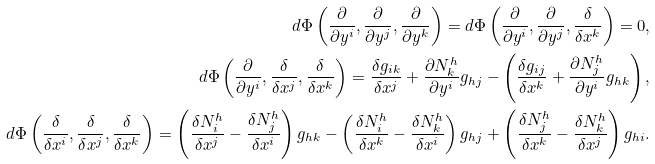<formula> <loc_0><loc_0><loc_500><loc_500>d \Phi \left ( \frac { \partial } { \partial y ^ { i } } , \frac { \partial } { \partial y ^ { j } } , \frac { \partial } { \partial y ^ { k } } \right ) = d \Phi \left ( \frac { \partial } { \partial y ^ { i } } , \frac { \partial } { \partial y ^ { j } } , \frac { \delta } { \delta x ^ { k } } \right ) = 0 , \\ d \Phi \left ( \frac { \partial } { \partial y ^ { i } } , \frac { \delta } { \delta x ^ { j } } , \frac { \delta } { \delta x ^ { k } } \right ) = \frac { \delta g _ { i k } } { \delta x ^ { j } } + \frac { \partial N ^ { h } _ { k } } { \partial y ^ { i } } g _ { h j } - \left ( \frac { \delta g _ { i j } } { \delta x ^ { k } } + \frac { \partial N ^ { h } _ { j } } { \partial y ^ { i } } g _ { h k } \right ) , \\ d \Phi \left ( \frac { \delta } { \delta x ^ { i } } , \frac { \delta } { \delta x ^ { j } } , \frac { \delta } { \delta x ^ { k } } \right ) = \left ( \frac { \delta N ^ { h } _ { i } } { \delta x ^ { j } } - \frac { \delta N ^ { h } _ { j } } { \delta x ^ { i } } \right ) g _ { h k } - \left ( \frac { \delta N ^ { h } _ { i } } { \delta x ^ { k } } - \frac { \delta N ^ { h } _ { k } } { \delta x ^ { i } } \right ) g _ { h j } + \left ( \frac { \delta N ^ { h } _ { j } } { \delta x ^ { k } } - \frac { \delta N ^ { h } _ { k } } { \delta x ^ { j } } \right ) g _ { h i } .</formula> 